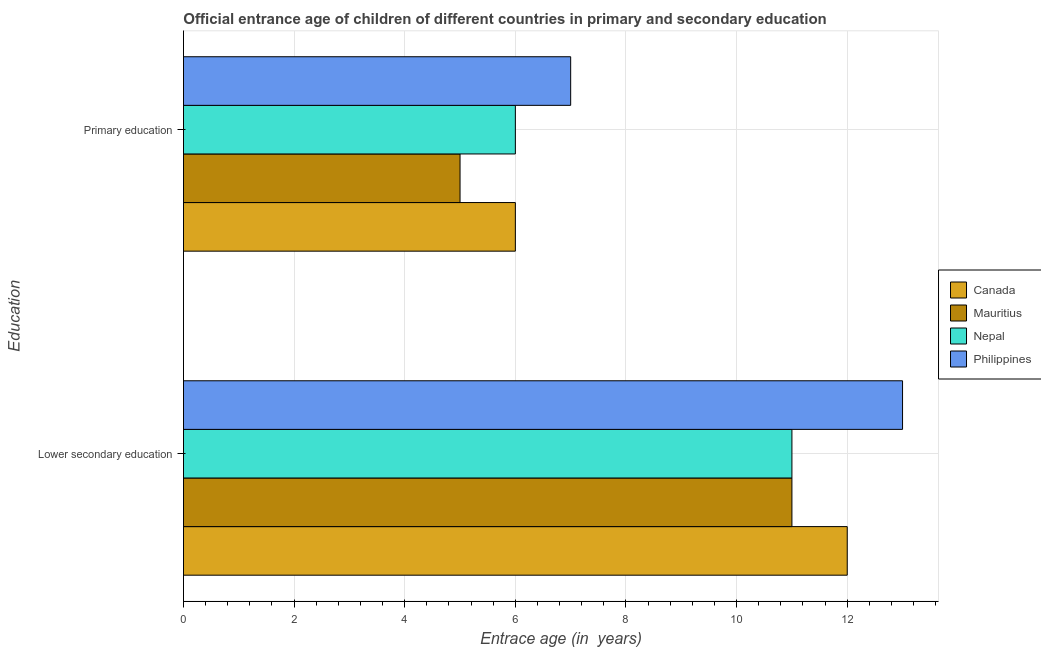How many groups of bars are there?
Keep it short and to the point. 2. Are the number of bars per tick equal to the number of legend labels?
Offer a terse response. Yes. How many bars are there on the 1st tick from the top?
Ensure brevity in your answer.  4. How many bars are there on the 1st tick from the bottom?
Offer a very short reply. 4. What is the label of the 1st group of bars from the top?
Make the answer very short. Primary education. What is the entrance age of chiildren in primary education in Philippines?
Make the answer very short. 7. Across all countries, what is the maximum entrance age of children in lower secondary education?
Keep it short and to the point. 13. Across all countries, what is the minimum entrance age of chiildren in primary education?
Ensure brevity in your answer.  5. In which country was the entrance age of children in lower secondary education minimum?
Your answer should be very brief. Mauritius. What is the total entrance age of children in lower secondary education in the graph?
Your response must be concise. 47. What is the difference between the entrance age of chiildren in primary education in Nepal and that in Mauritius?
Ensure brevity in your answer.  1. What is the difference between the entrance age of children in lower secondary education in Philippines and the entrance age of chiildren in primary education in Canada?
Provide a succinct answer. 7. What is the average entrance age of chiildren in primary education per country?
Offer a very short reply. 6. What is the difference between the entrance age of chiildren in primary education and entrance age of children in lower secondary education in Mauritius?
Your response must be concise. -6. What is the ratio of the entrance age of chiildren in primary education in Mauritius to that in Nepal?
Give a very brief answer. 0.83. What does the 1st bar from the top in Lower secondary education represents?
Ensure brevity in your answer.  Philippines. What does the 3rd bar from the bottom in Lower secondary education represents?
Make the answer very short. Nepal. How many bars are there?
Your answer should be very brief. 8. Are all the bars in the graph horizontal?
Ensure brevity in your answer.  Yes. What is the difference between two consecutive major ticks on the X-axis?
Provide a succinct answer. 2. Are the values on the major ticks of X-axis written in scientific E-notation?
Keep it short and to the point. No. Does the graph contain any zero values?
Your answer should be compact. No. Does the graph contain grids?
Make the answer very short. Yes. What is the title of the graph?
Keep it short and to the point. Official entrance age of children of different countries in primary and secondary education. What is the label or title of the X-axis?
Your answer should be compact. Entrace age (in  years). What is the label or title of the Y-axis?
Give a very brief answer. Education. What is the Entrace age (in  years) of Canada in Lower secondary education?
Your answer should be very brief. 12. What is the Entrace age (in  years) in Nepal in Lower secondary education?
Provide a short and direct response. 11. What is the Entrace age (in  years) of Canada in Primary education?
Offer a terse response. 6. What is the Entrace age (in  years) in Mauritius in Primary education?
Your response must be concise. 5. Across all Education, what is the maximum Entrace age (in  years) in Canada?
Your response must be concise. 12. Across all Education, what is the maximum Entrace age (in  years) of Philippines?
Your answer should be compact. 13. Across all Education, what is the minimum Entrace age (in  years) of Nepal?
Make the answer very short. 6. What is the total Entrace age (in  years) of Mauritius in the graph?
Keep it short and to the point. 16. What is the total Entrace age (in  years) in Philippines in the graph?
Make the answer very short. 20. What is the difference between the Entrace age (in  years) of Canada in Lower secondary education and that in Primary education?
Offer a terse response. 6. What is the difference between the Entrace age (in  years) of Nepal in Lower secondary education and that in Primary education?
Keep it short and to the point. 5. What is the difference between the Entrace age (in  years) in Canada in Lower secondary education and the Entrace age (in  years) in Mauritius in Primary education?
Your answer should be very brief. 7. What is the difference between the Entrace age (in  years) of Canada in Lower secondary education and the Entrace age (in  years) of Nepal in Primary education?
Give a very brief answer. 6. What is the difference between the Entrace age (in  years) in Canada in Lower secondary education and the Entrace age (in  years) in Philippines in Primary education?
Make the answer very short. 5. What is the difference between the Entrace age (in  years) in Mauritius in Lower secondary education and the Entrace age (in  years) in Nepal in Primary education?
Your answer should be compact. 5. What is the difference between the Entrace age (in  years) of Mauritius in Lower secondary education and the Entrace age (in  years) of Philippines in Primary education?
Give a very brief answer. 4. What is the average Entrace age (in  years) in Philippines per Education?
Your response must be concise. 10. What is the difference between the Entrace age (in  years) of Canada and Entrace age (in  years) of Mauritius in Lower secondary education?
Provide a succinct answer. 1. What is the difference between the Entrace age (in  years) in Mauritius and Entrace age (in  years) in Philippines in Lower secondary education?
Offer a terse response. -2. What is the difference between the Entrace age (in  years) in Nepal and Entrace age (in  years) in Philippines in Lower secondary education?
Give a very brief answer. -2. What is the ratio of the Entrace age (in  years) in Mauritius in Lower secondary education to that in Primary education?
Offer a terse response. 2.2. What is the ratio of the Entrace age (in  years) in Nepal in Lower secondary education to that in Primary education?
Offer a very short reply. 1.83. What is the ratio of the Entrace age (in  years) in Philippines in Lower secondary education to that in Primary education?
Your response must be concise. 1.86. What is the difference between the highest and the second highest Entrace age (in  years) in Canada?
Your answer should be very brief. 6. 